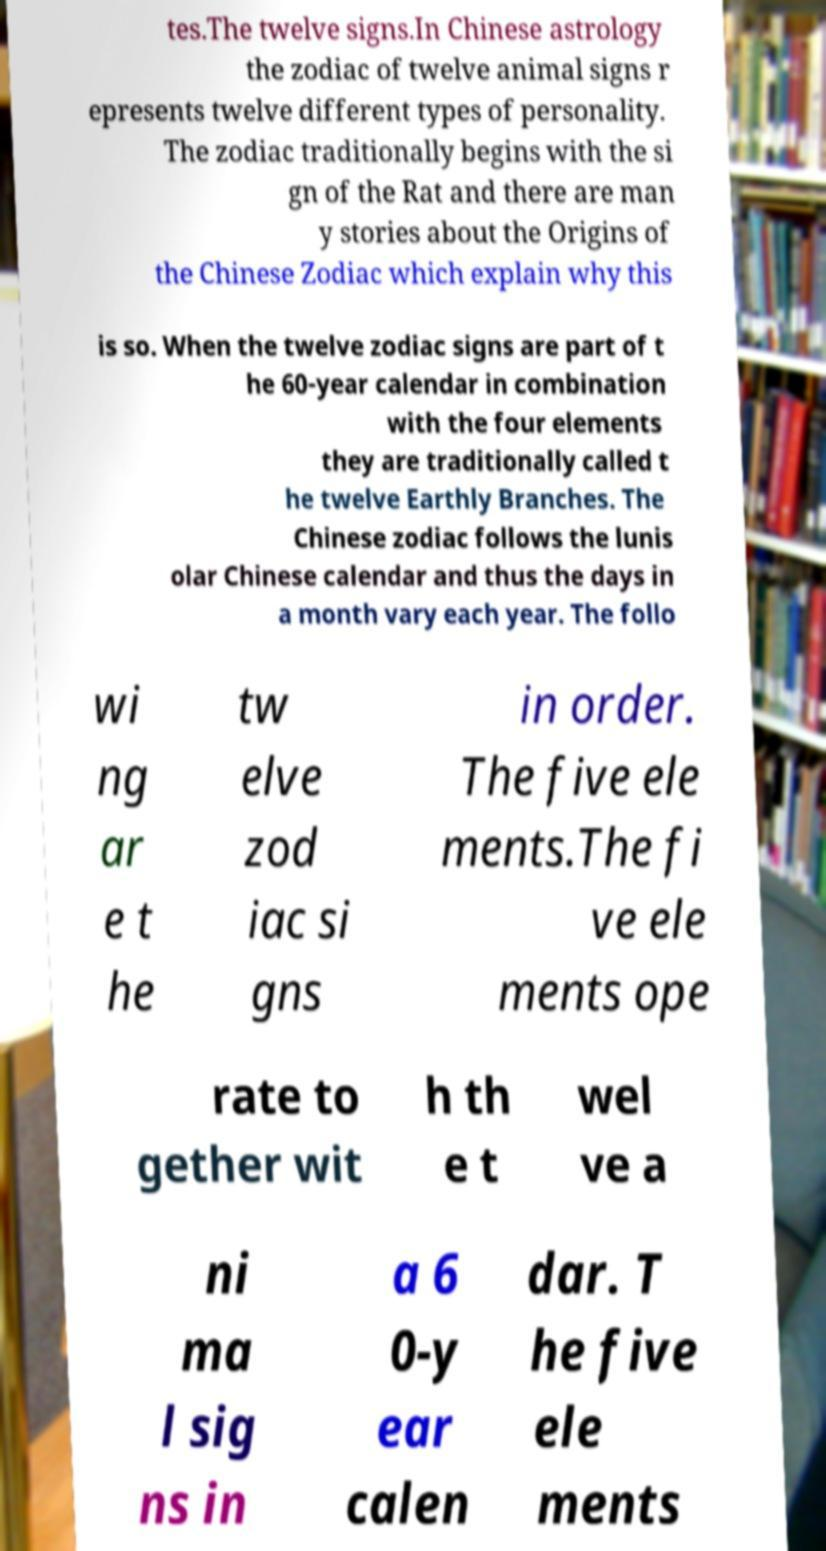There's text embedded in this image that I need extracted. Can you transcribe it verbatim? tes.The twelve signs.In Chinese astrology the zodiac of twelve animal signs r epresents twelve different types of personality. The zodiac traditionally begins with the si gn of the Rat and there are man y stories about the Origins of the Chinese Zodiac which explain why this is so. When the twelve zodiac signs are part of t he 60-year calendar in combination with the four elements they are traditionally called t he twelve Earthly Branches. The Chinese zodiac follows the lunis olar Chinese calendar and thus the days in a month vary each year. The follo wi ng ar e t he tw elve zod iac si gns in order. The five ele ments.The fi ve ele ments ope rate to gether wit h th e t wel ve a ni ma l sig ns in a 6 0-y ear calen dar. T he five ele ments 